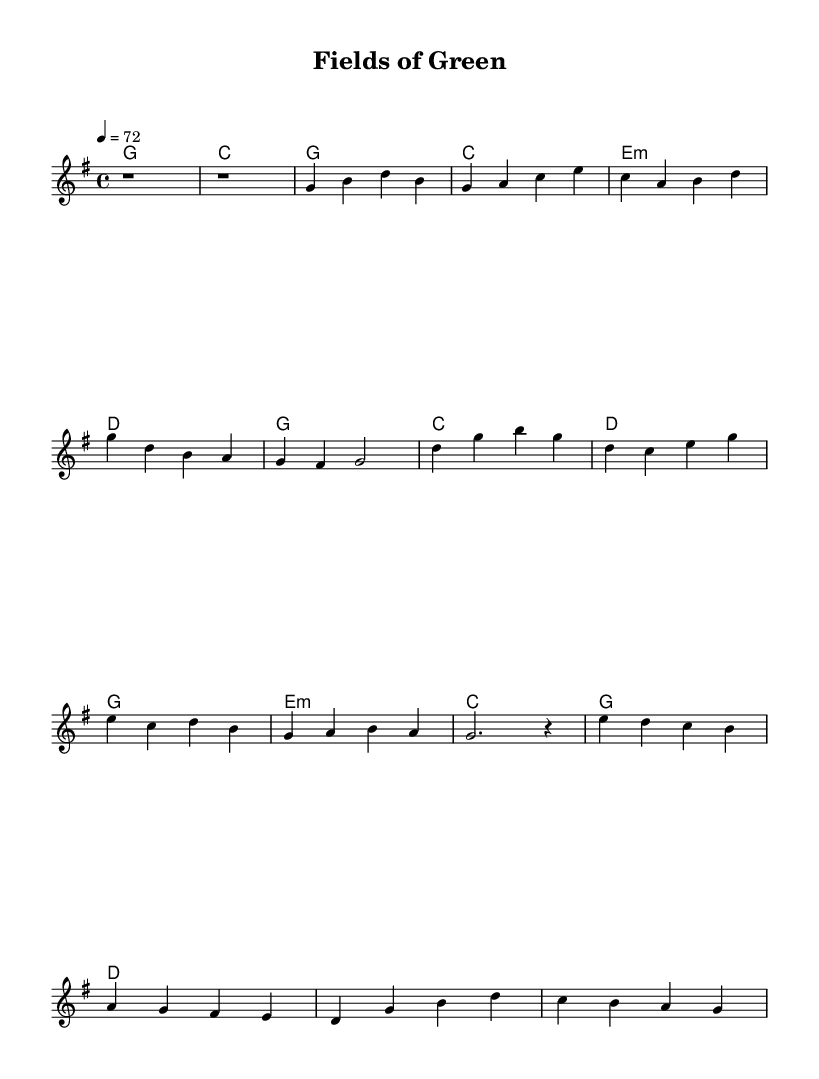What is the key signature of this music? The key signature is G major, which contains one sharp (F#).
Answer: G major What is the time signature of the piece? The time signature is 4/4, indicating that there are four beats per measure.
Answer: 4/4 What is the tempo marking of the piece? The tempo marking is 72 beats per minute, indicated by "4 = 72" in the score.
Answer: 72 How many measures are in the chorus section? The chorus section consists of four measures as indicated by the distinct chords and melody notations laid out.
Answer: 4 measures What is the last chord in the bridge? The last chord in the bridge is D major, which follows the progression that ends the bridge section.
Answer: D What is the structure of the song? The structure includes an intro, followed by a verse, a chorus, and a bridge, which reflects the typical format of country rock ballads.
Answer: Intro, Verse, Chorus, Bridge Which instrument is primarily featured in the score? The primary instrument featured in the score is the voice, as indicated by the staff labeled "Voice".
Answer: Voice 